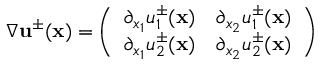Convert formula to latex. <formula><loc_0><loc_0><loc_500><loc_500>\nabla { \mathbf u } ^ { \pm } ( { \mathbf x } ) = \left ( \begin{array} { l l } { \partial _ { x _ { 1 } } u _ { 1 } ^ { \pm } ( { \mathbf x } ) } & { \partial _ { x _ { 2 } } u _ { 1 } ^ { \pm } ( { \mathbf x } ) } \\ { \partial _ { x _ { 1 } } u _ { 2 } ^ { \pm } ( { \mathbf x } ) } & { \partial _ { x _ { 2 } } u _ { 2 } ^ { \pm } ( { \mathbf x } ) } \end{array} \right )</formula> 